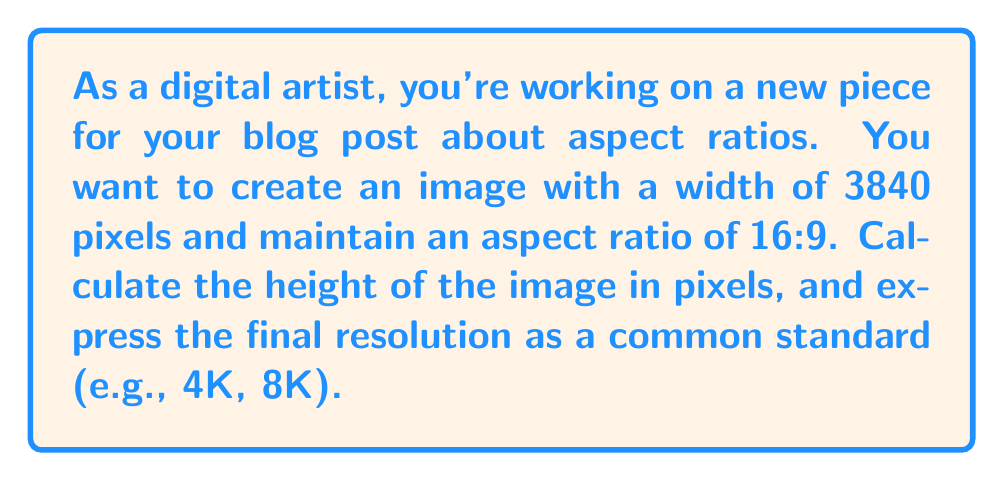Provide a solution to this math problem. To solve this problem, we'll follow these steps:

1. Understand the given information:
   - Width = 3840 pixels
   - Aspect ratio = 16:9

2. Set up the aspect ratio equation:
   $\frac{\text{width}}{\text{height}} = \frac{16}{9}$

3. Substitute the known width:
   $\frac{3840}{\text{height}} = \frac{16}{9}$

4. Cross multiply to isolate the height:
   $9 \cdot 3840 = 16 \cdot \text{height}$
   $34560 = 16 \cdot \text{height}$

5. Solve for height:
   $\text{height} = \frac{34560}{16} = 2160$ pixels

6. Express the final resolution:
   3840 x 2160 pixels

7. Identify the standard resolution:
   This resolution (3840 x 2160) is commonly known as 4K UHD (Ultra High Definition).

The aspect ratio can be verified:
$\frac{3840}{2160} = \frac{16}{9} = 1.7777...$
Answer: The height of the image should be 2160 pixels, resulting in a resolution of 3840 x 2160, which is known as 4K UHD. 